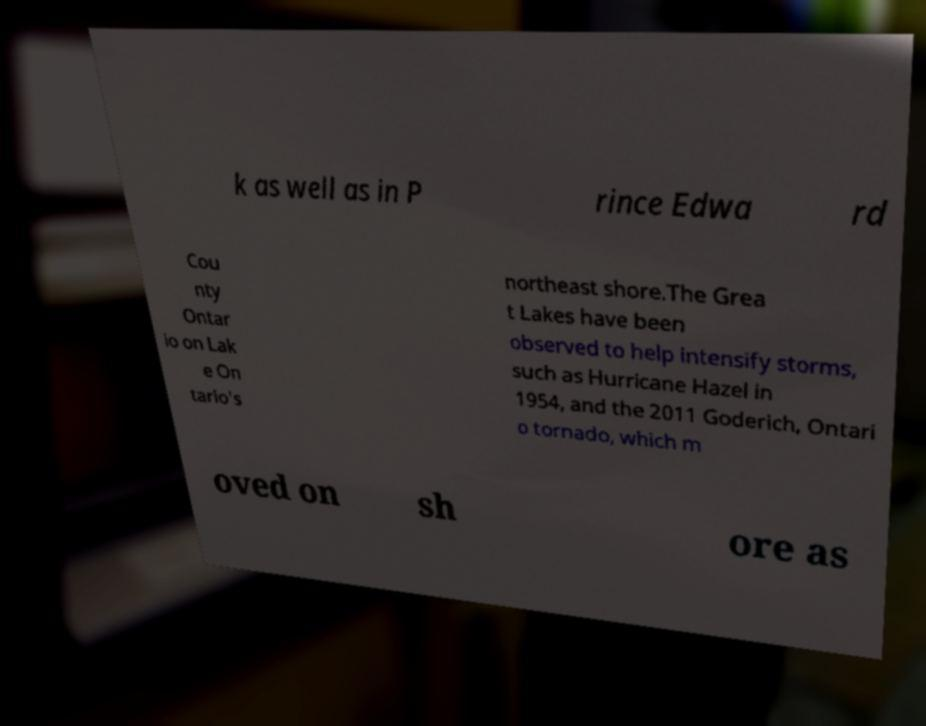I need the written content from this picture converted into text. Can you do that? k as well as in P rince Edwa rd Cou nty Ontar io on Lak e On tario's northeast shore.The Grea t Lakes have been observed to help intensify storms, such as Hurricane Hazel in 1954, and the 2011 Goderich, Ontari o tornado, which m oved on sh ore as 